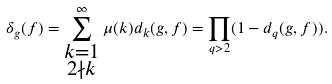<formula> <loc_0><loc_0><loc_500><loc_500>\delta _ { g } ( f ) = \sum _ { \substack { { k = 1 } \\ { 2 \nmid k } } } ^ { \infty } \mu ( k ) d _ { k } ( g , f ) = \prod _ { q > 2 } ( 1 - d _ { q } ( g , f ) ) .</formula> 